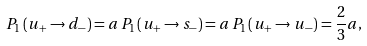<formula> <loc_0><loc_0><loc_500><loc_500>P _ { 1 } \left ( u _ { + } \rightarrow d _ { - } \right ) = a \, P _ { 1 } \left ( u _ { + } \rightarrow s _ { - } \right ) = a \, P _ { 1 } \left ( u _ { + } \rightarrow u _ { - } \right ) = \frac { 2 } { 3 } a ,</formula> 